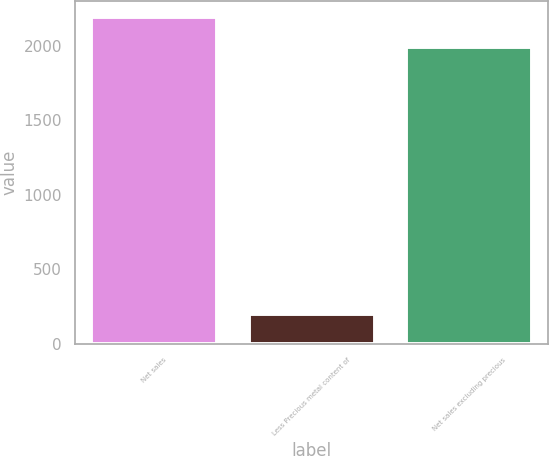<chart> <loc_0><loc_0><loc_500><loc_500><bar_chart><fcel>Net sales<fcel>Less Precious metal content of<fcel>Net sales excluding precious<nl><fcel>2193.7<fcel>199.9<fcel>1993.8<nl></chart> 